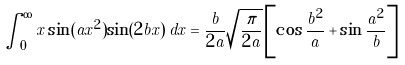<formula> <loc_0><loc_0><loc_500><loc_500>\int _ { 0 } ^ { \infty } x \sin ( a x ^ { 2 } ) \sin ( 2 b x ) \, d x = \frac { b } { 2 a } \sqrt { \frac { \pi } { 2 a } } \left [ \cos \frac { b ^ { 2 } } { a } + \sin \frac { a ^ { 2 } } { b } \right ]</formula> 